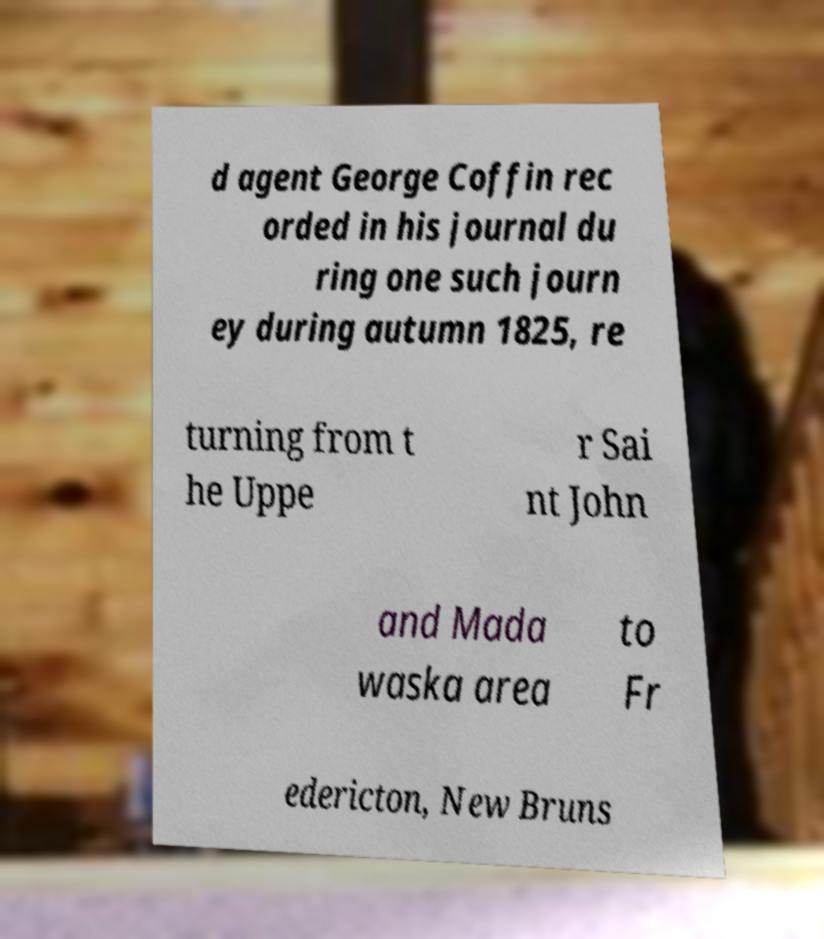There's text embedded in this image that I need extracted. Can you transcribe it verbatim? d agent George Coffin rec orded in his journal du ring one such journ ey during autumn 1825, re turning from t he Uppe r Sai nt John and Mada waska area to Fr edericton, New Bruns 